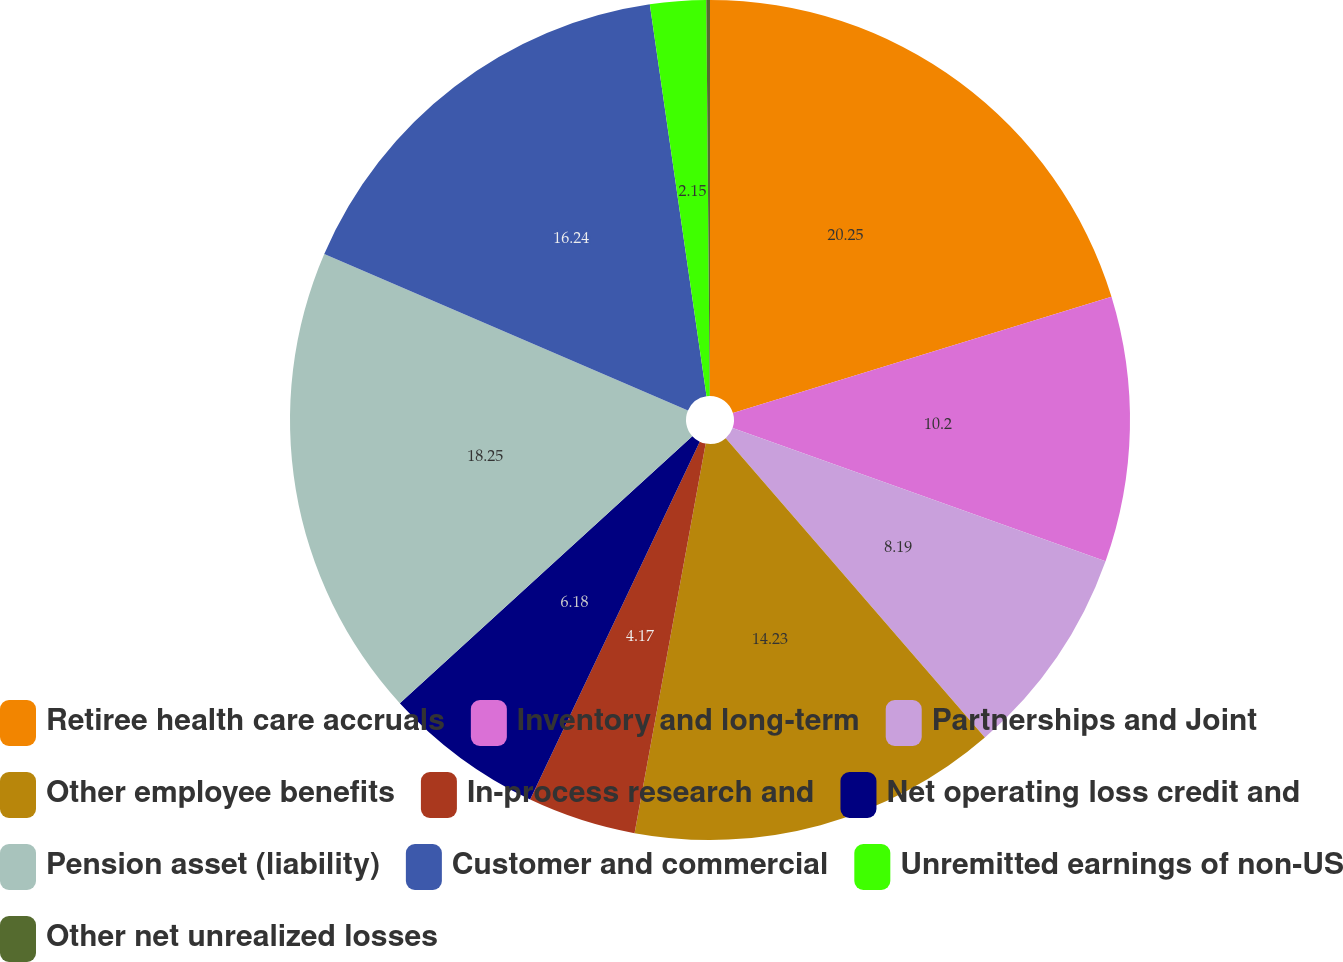Convert chart. <chart><loc_0><loc_0><loc_500><loc_500><pie_chart><fcel>Retiree health care accruals<fcel>Inventory and long-term<fcel>Partnerships and Joint<fcel>Other employee benefits<fcel>In-process research and<fcel>Net operating loss credit and<fcel>Pension asset (liability)<fcel>Customer and commercial<fcel>Unremitted earnings of non-US<fcel>Other net unrealized losses<nl><fcel>20.26%<fcel>10.2%<fcel>8.19%<fcel>14.23%<fcel>4.17%<fcel>6.18%<fcel>18.25%<fcel>16.24%<fcel>2.15%<fcel>0.14%<nl></chart> 